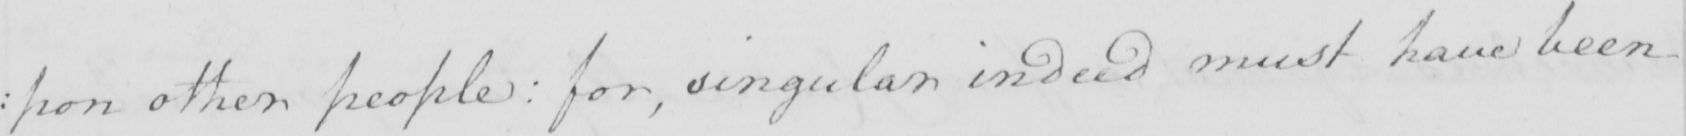Can you read and transcribe this handwriting? : pon other people :  for , singular indeed must have been 